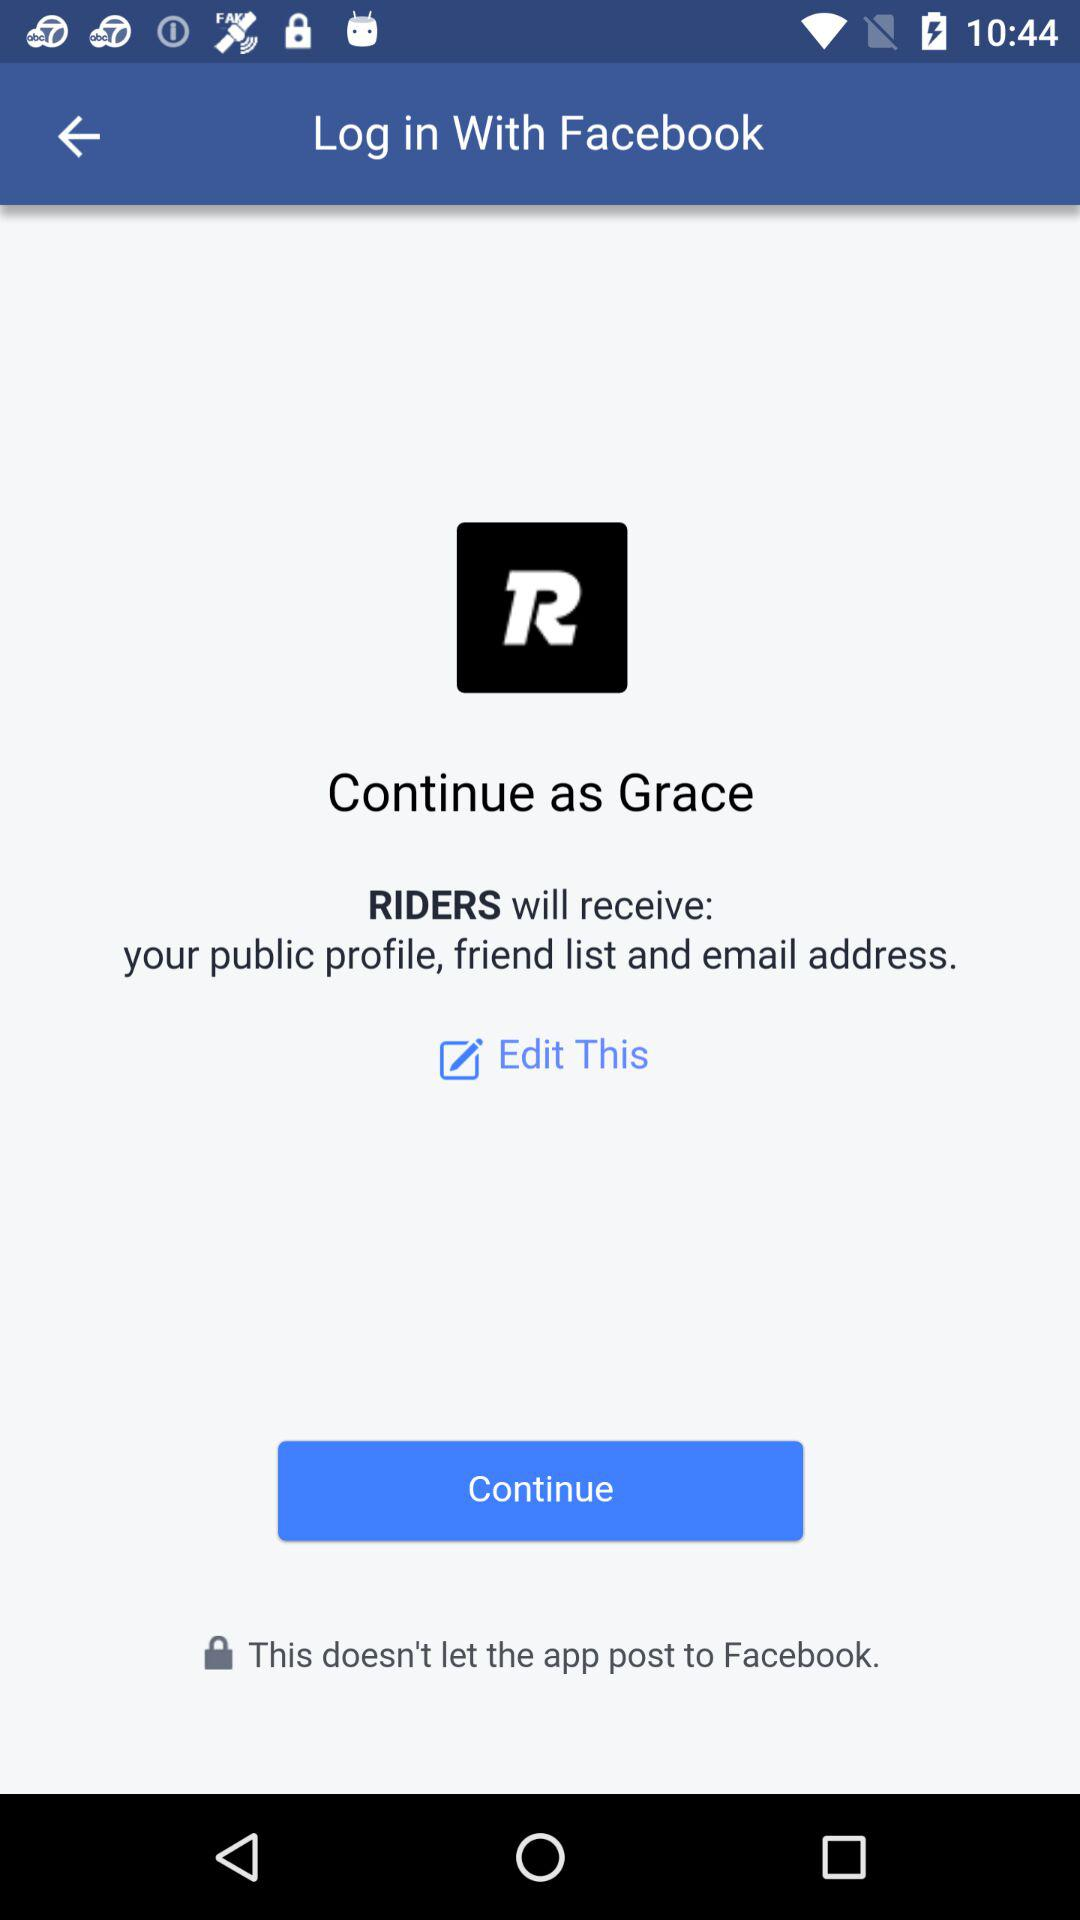What information will riders receive? Riders will receive your public profile, friend list and email address. 